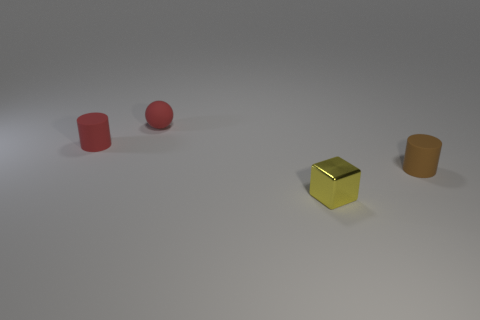What number of red rubber objects have the same shape as the metallic object?
Keep it short and to the point. 0. What number of cylinders are matte things or small red metallic things?
Your answer should be very brief. 2. Do the thing that is in front of the small brown cylinder and the matte thing that is right of the yellow object have the same shape?
Offer a very short reply. No. What is the tiny cube made of?
Offer a very short reply. Metal. There is a tiny rubber object that is the same color as the tiny rubber ball; what shape is it?
Keep it short and to the point. Cylinder. What number of brown cylinders have the same size as the red sphere?
Ensure brevity in your answer.  1. How many things are either things that are on the left side of the small red rubber sphere or matte cylinders to the left of the brown rubber thing?
Provide a succinct answer. 1. Does the red thing that is in front of the red rubber ball have the same material as the tiny cylinder to the right of the red rubber ball?
Your response must be concise. Yes. The thing in front of the rubber object that is to the right of the ball is what shape?
Give a very brief answer. Cube. Is there any other thing that is the same color as the small metallic block?
Keep it short and to the point. No. 